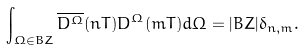Convert formula to latex. <formula><loc_0><loc_0><loc_500><loc_500>\int _ { \Omega \in B Z } \overline { D ^ { \Omega } } ( n T ) D ^ { \Omega } ( m T ) d \Omega = | B Z | \delta _ { n , m } .</formula> 